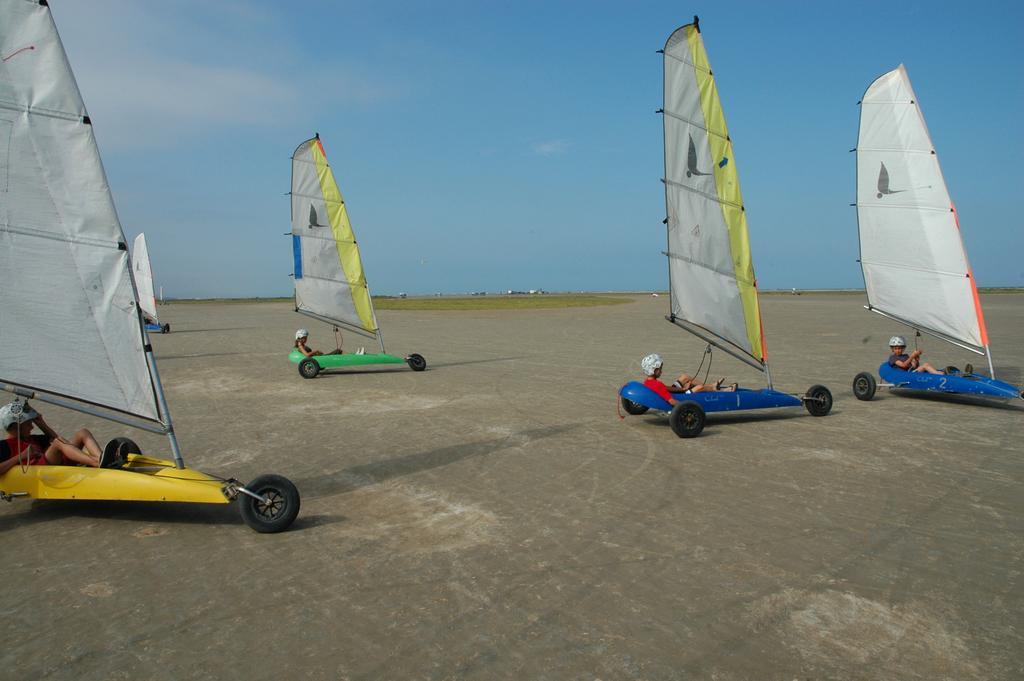In one or two sentences, can you explain what this image depicts? In this image I can see few people wearing the helmets and I can see these people are land-sailing. In the background I can see the sky. 